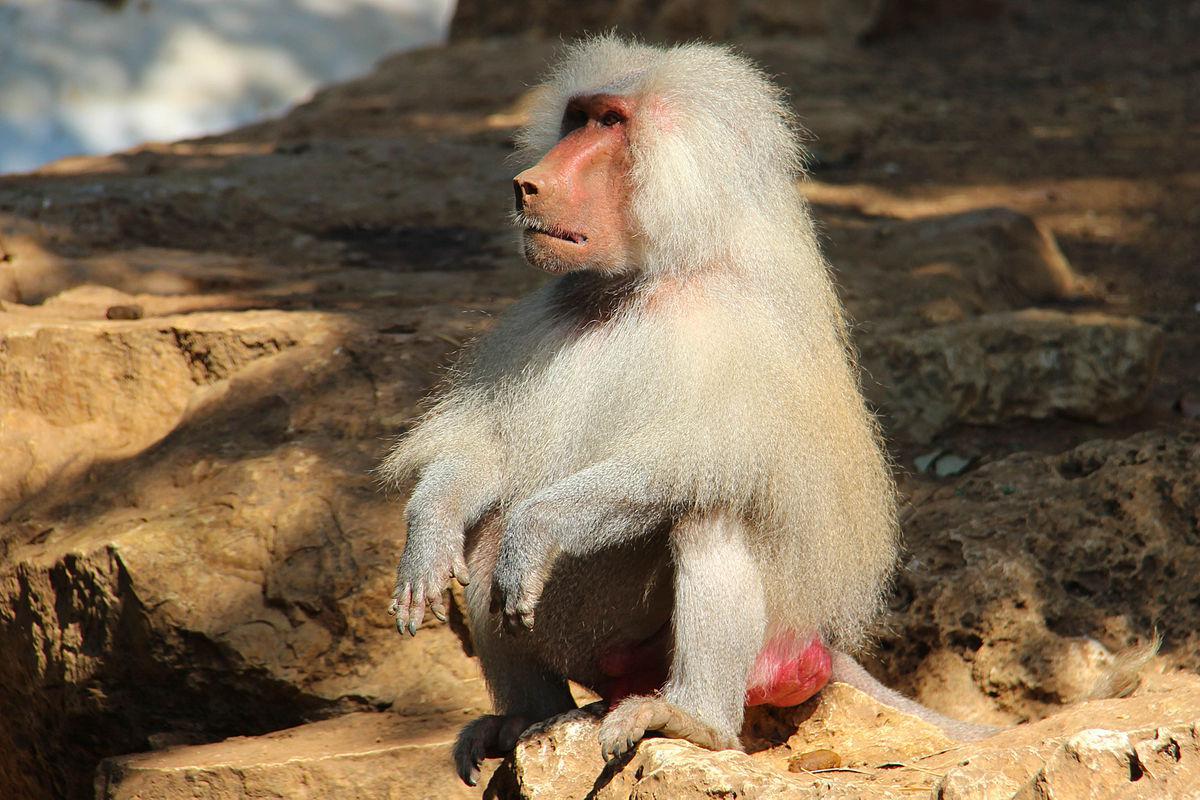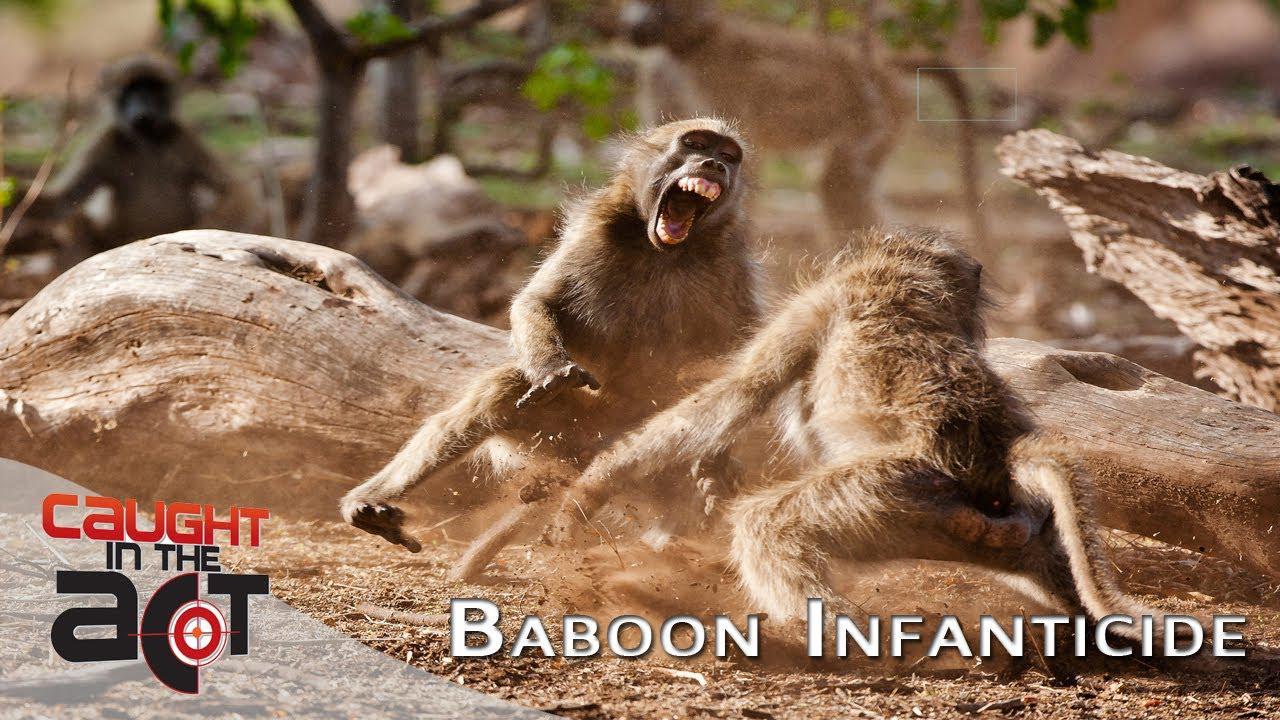The first image is the image on the left, the second image is the image on the right. Considering the images on both sides, is "The right image features two adult baboons stting with a small baby baboon." valid? Answer yes or no. No. 